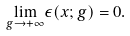<formula> <loc_0><loc_0><loc_500><loc_500>\underset { g \rightarrow + \infty } { \lim } \epsilon ( x ; g ) = 0 .</formula> 